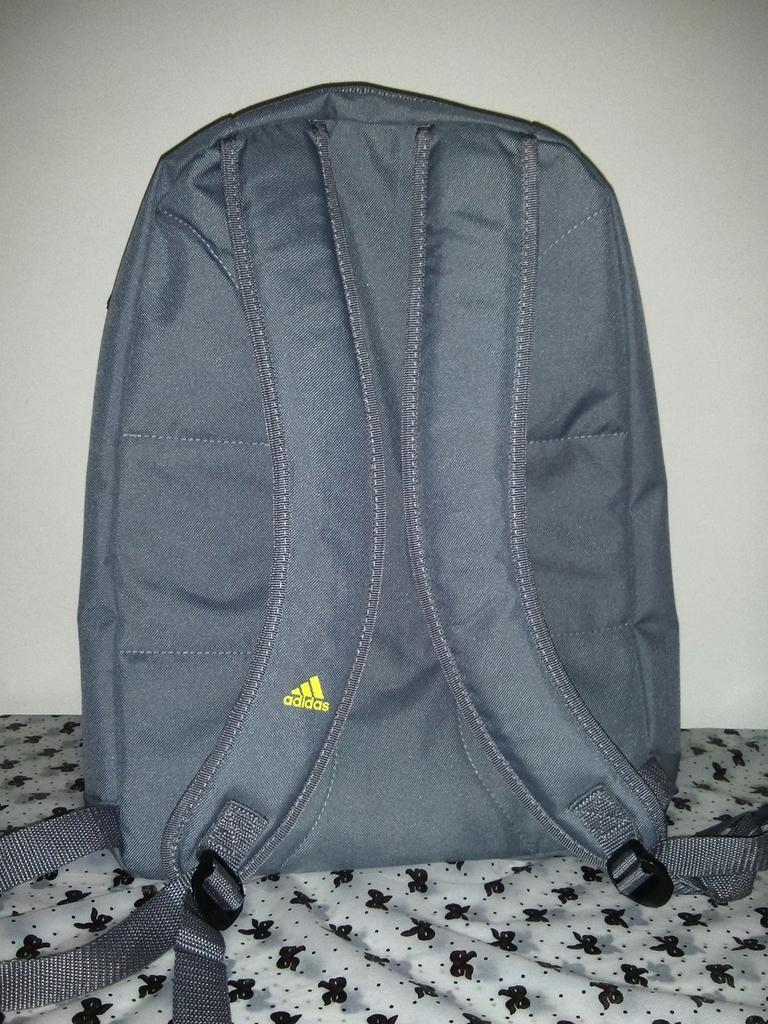<image>
Relay a brief, clear account of the picture shown. A grey adidas back pack on a white sheet with black bows on it. 